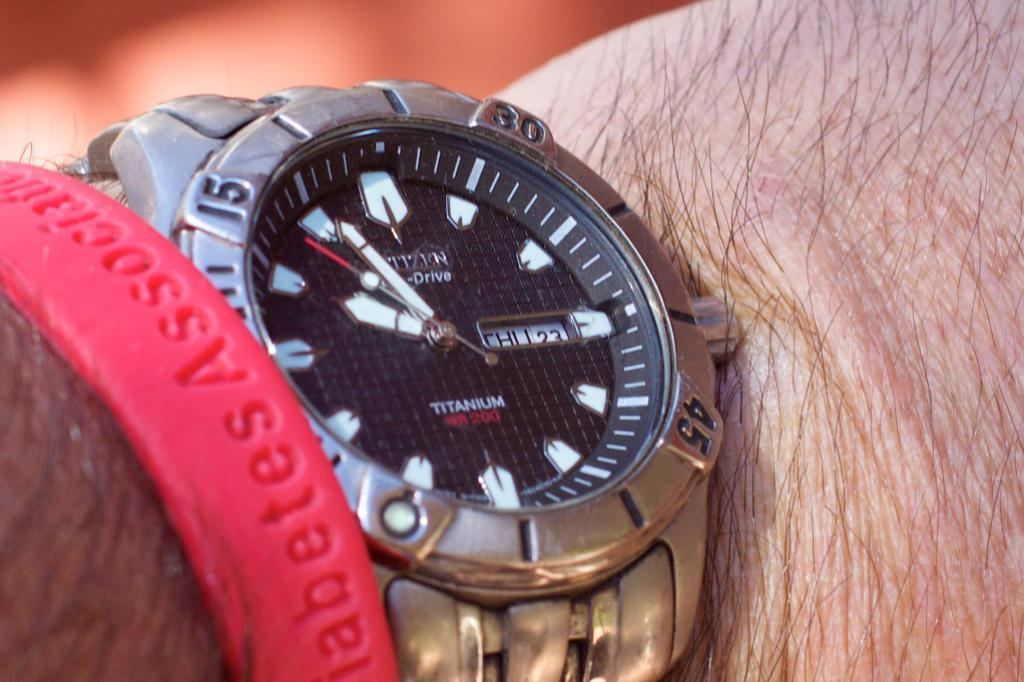Provide a one-sentence caption for the provided image. The nice silver watch is from the company Citizen. 